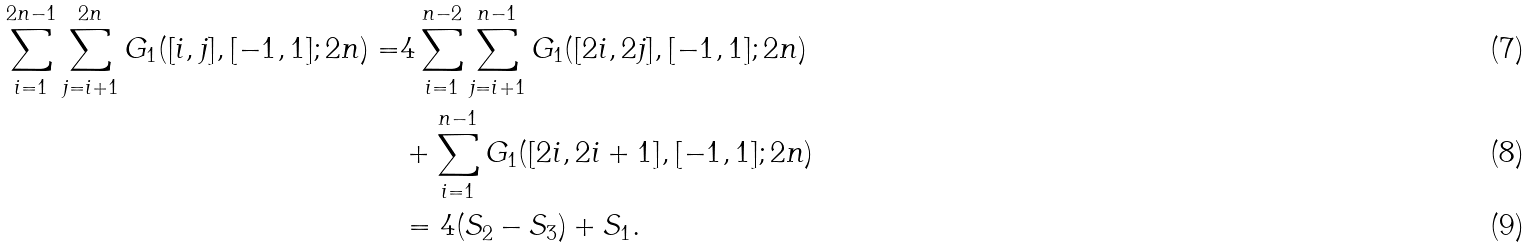<formula> <loc_0><loc_0><loc_500><loc_500>\sum _ { i = 1 } ^ { 2 n - 1 } \sum _ { j = i + 1 } ^ { 2 n } G _ { 1 } ( [ i , j ] , [ - 1 , 1 ] ; 2 n ) = & 4 \sum _ { i = 1 } ^ { n - 2 } \sum _ { j = i + 1 } ^ { n - 1 } G _ { 1 } ( [ 2 i , 2 j ] , [ - 1 , 1 ] ; 2 n ) \\ & + \sum _ { i = 1 } ^ { n - 1 } G _ { 1 } ( [ 2 i , 2 i + 1 ] , [ - 1 , 1 ] ; 2 n ) \\ & = 4 ( S _ { 2 } - S _ { 3 } ) + S _ { 1 } .</formula> 